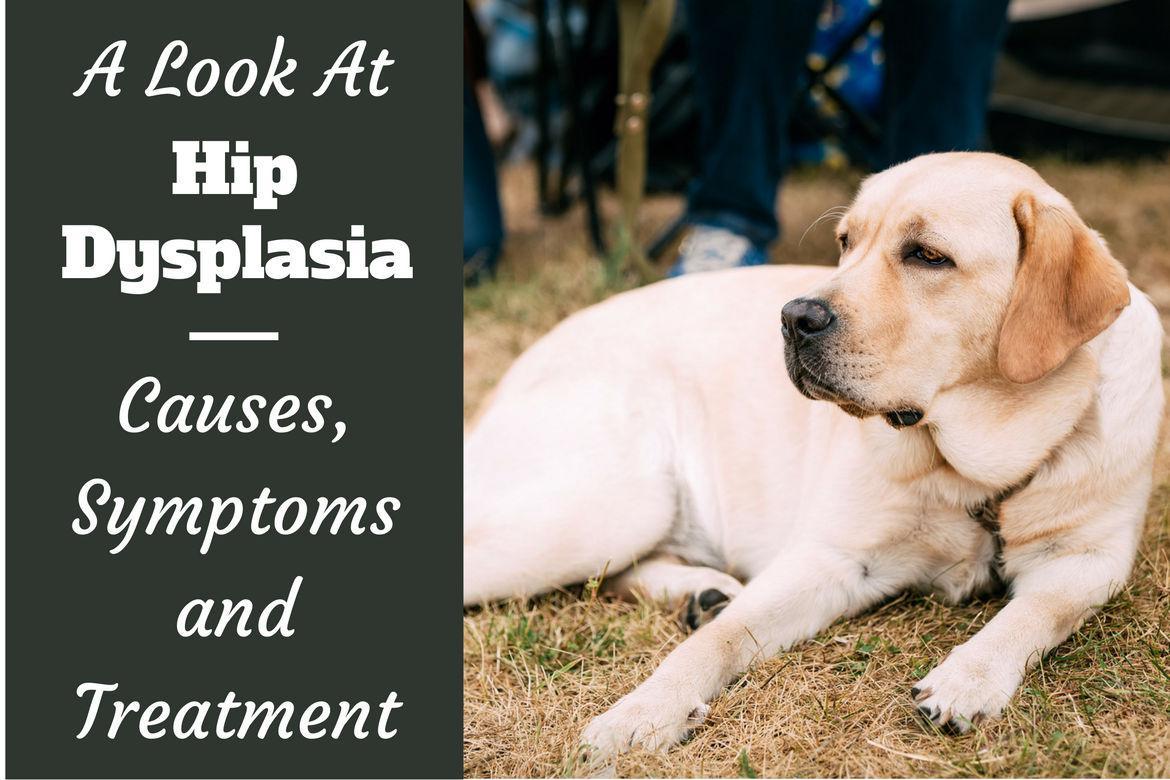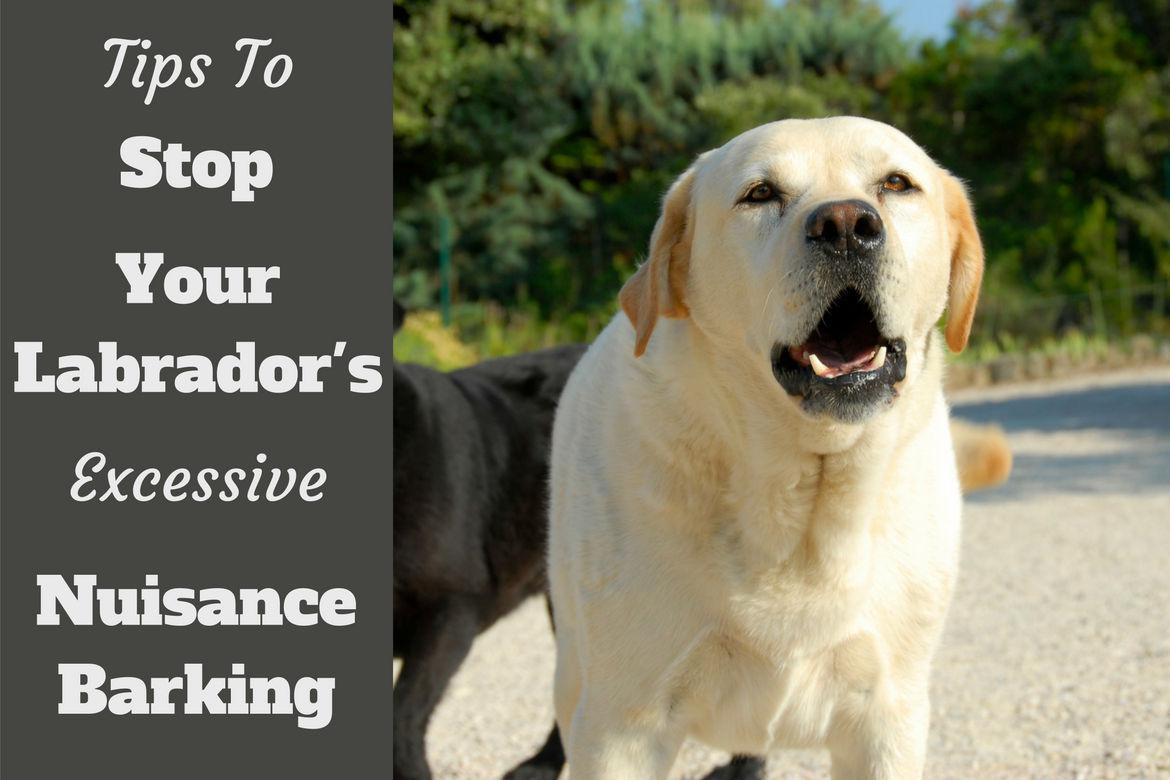The first image is the image on the left, the second image is the image on the right. Considering the images on both sides, is "Only one image shows a dog with mouth opened." valid? Answer yes or no. Yes. The first image is the image on the left, the second image is the image on the right. Given the left and right images, does the statement "The dog on the right is on the grass." hold true? Answer yes or no. No. 